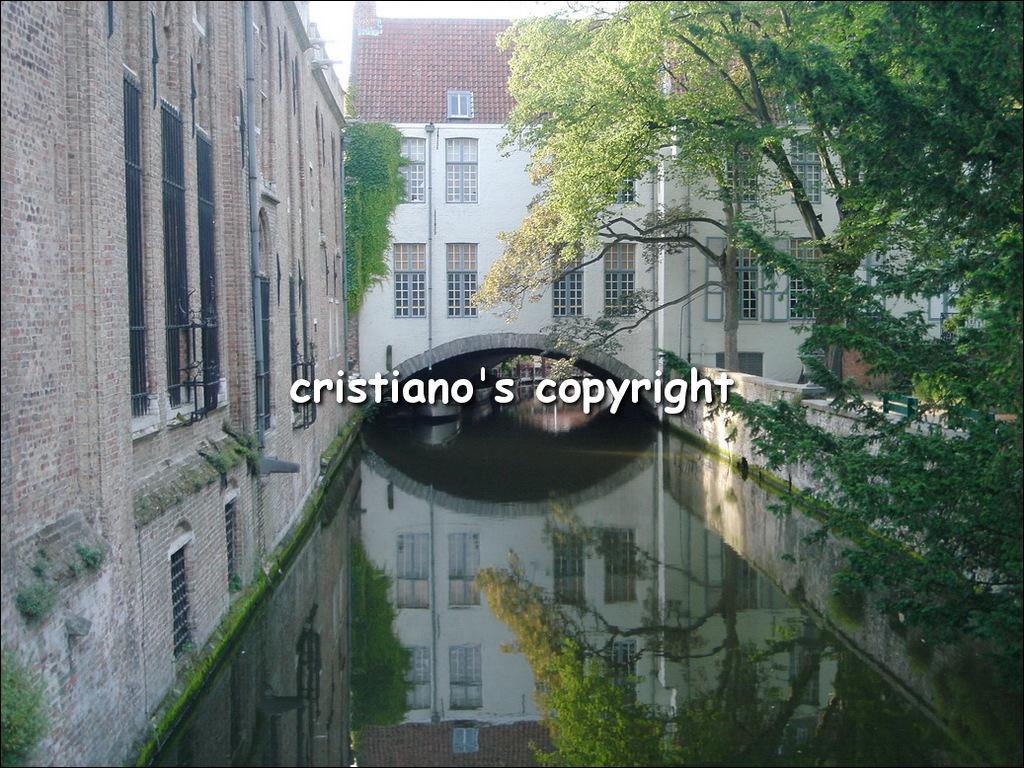What is the main feature at the center of the image? There is water at the center of the image. What type of vegetation can be seen at the right side of the image? There are trees at the right side of the image. What type of structures are present in the image? There are buildings in the image, including a brick building at the left side. What are the characteristics of the brick building? The brick building has windows and a pipe. Can you see any insects kissing in the image? There are no insects or any kissing activity present in the image. 